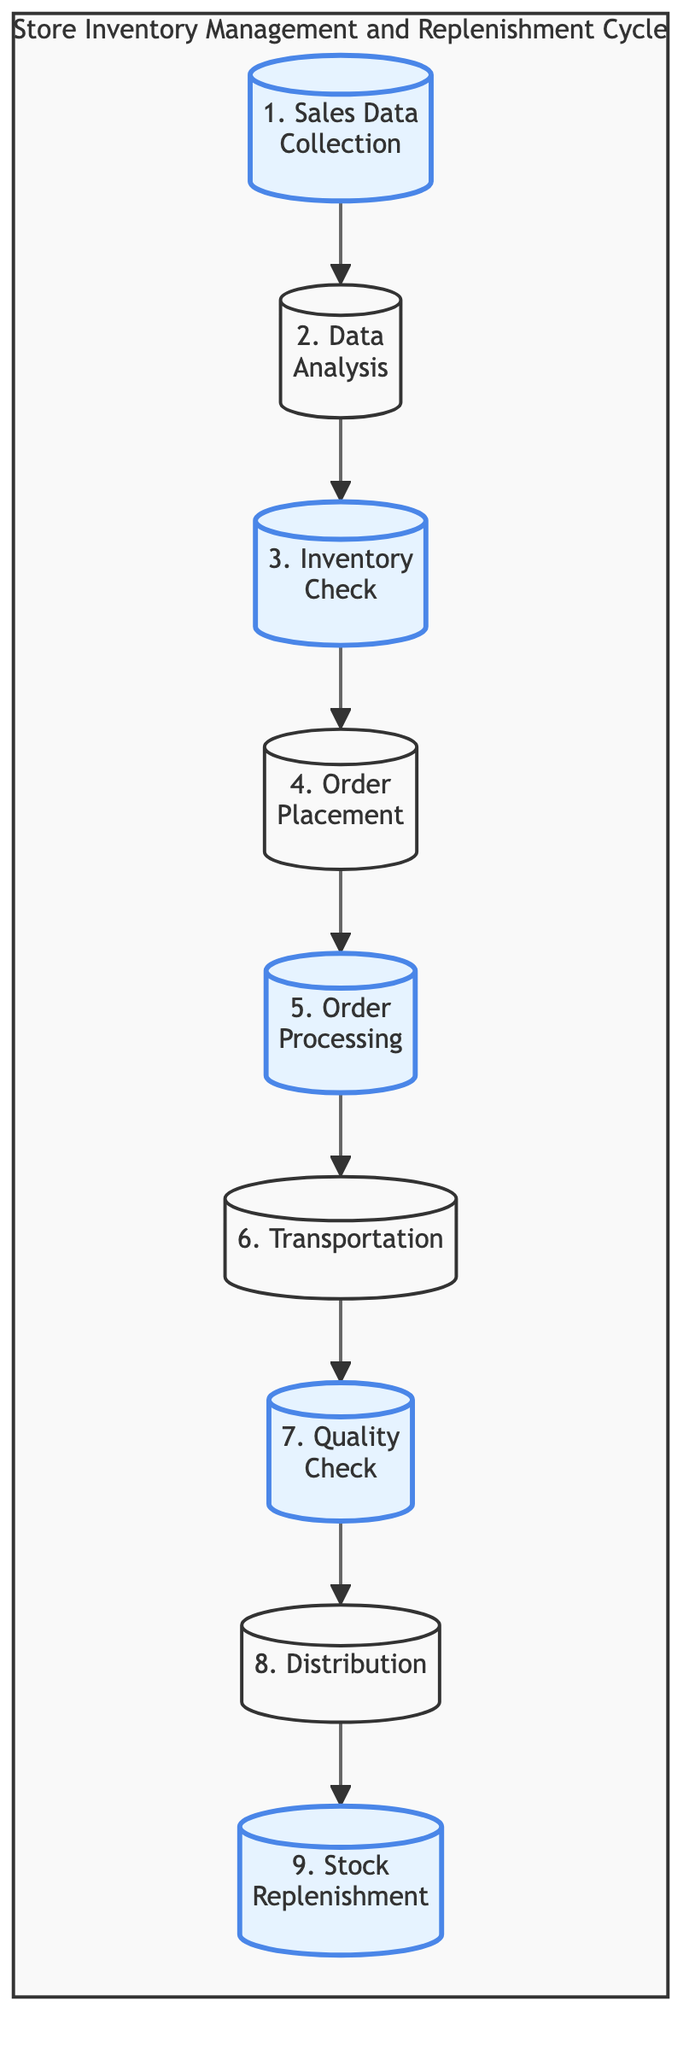What is the first stage in the Store Inventory Management and Replenishment Cycle? The first stage is "Sales Data Collection" as indicated at the top of the flowchart. It is the starting point of the entire cycle.
Answer: Sales Data Collection How many total stages are represented in the cycle? By counting the individual stages listed in the flowchart, there are nine distinct stages in the cycle.
Answer: 9 What is the last stage of the Store Inventory Management and Replenishment Cycle? The last stage in the flowchart is "Stock Replenishment," which is the final step after distribution.
Answer: Stock Replenishment Which stage comes immediately after "Inventory Check"? The stage following "Inventory Check" is "Order Placement," indicating the process of placing orders for products that require replenishment.
Answer: Order Placement What role do the "Supplier Databases" play in the cycle? "Supplier Databases" are involved in the "Order Placement" stage, as they are used to identify and connect with suppliers for product ordering.
Answer: Order Placement What action occurs after "Quality Check"? After the "Quality Check" stage, the next action taken is "Distribution," where products are distributed from regional centers to stores.
Answer: Distribution Identify the connection between "Transportation" and "Order Processing." "Transportation" connects to "Order Processing" as they are consecutive stages in the cycle, with "Order Processing" involving the preparation of shipments that will then be transported.
Answer: Order Processing In which stage are "Inventory Systems" utilized? "Inventory Systems" are utilized in the "Stock Replenishment" stage, where products received are accounted for and updated in the inventory records.
Answer: Stock Replenishment How is "Data Analysis" connected to "Sales Data Collection"? "Data Analysis" depends on "Sales Data Collection," as the analysis occurs based on the data collected from sales reports gathered in the first stage.
Answer: Sales Data Collection 